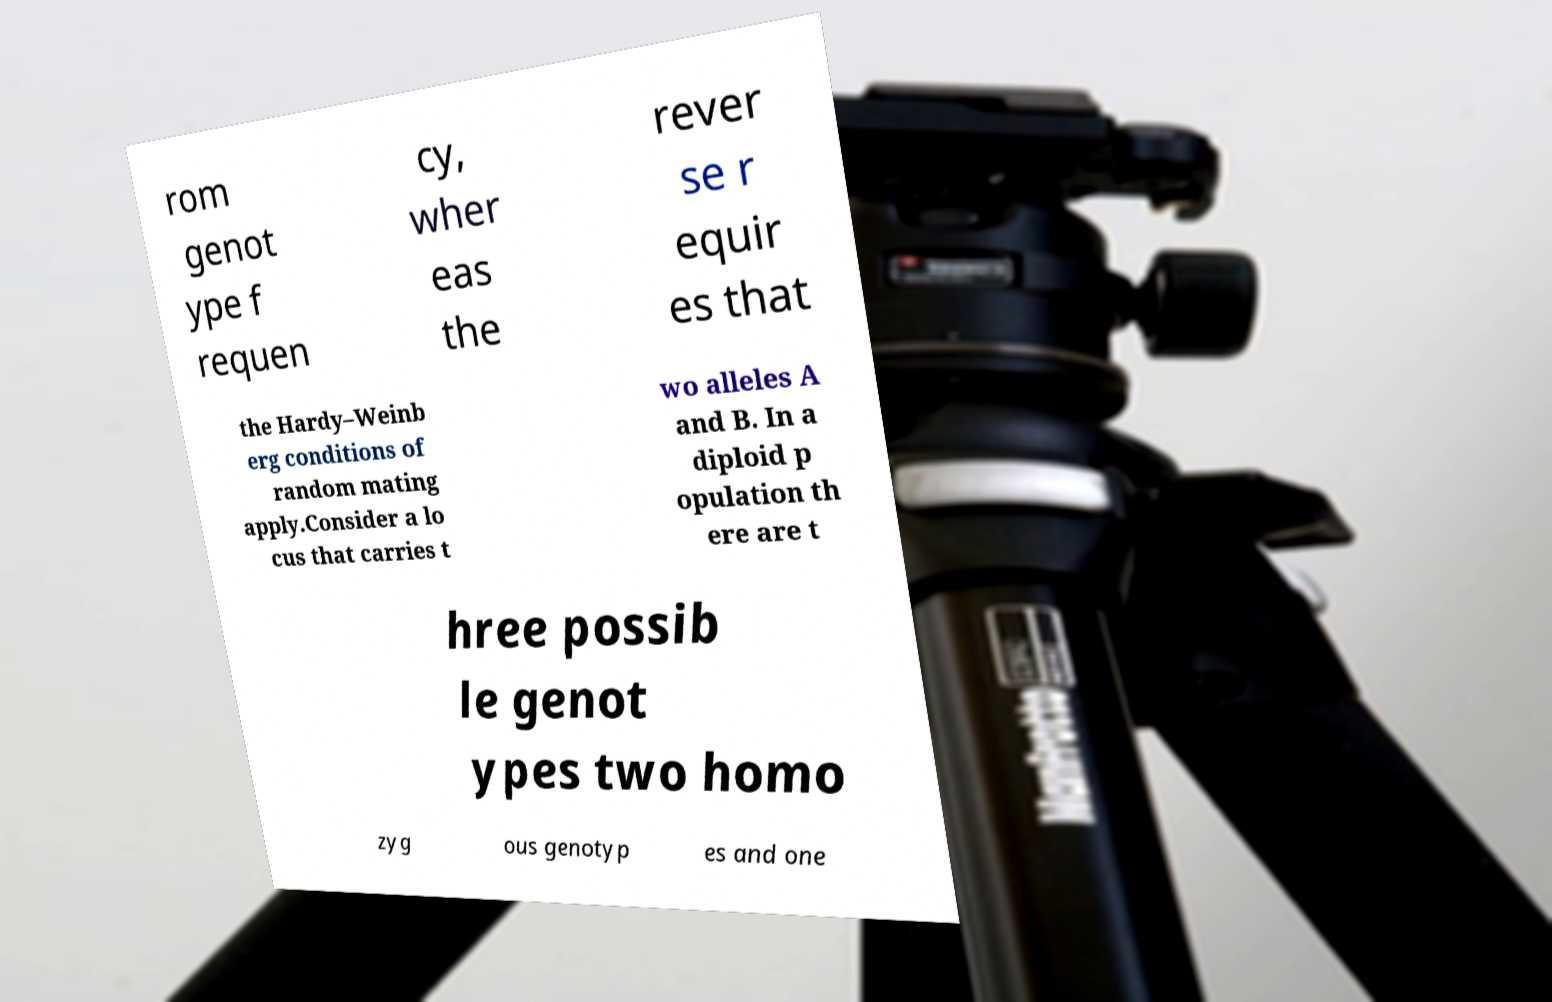I need the written content from this picture converted into text. Can you do that? rom genot ype f requen cy, wher eas the rever se r equir es that the Hardy–Weinb erg conditions of random mating apply.Consider a lo cus that carries t wo alleles A and B. In a diploid p opulation th ere are t hree possib le genot ypes two homo zyg ous genotyp es and one 